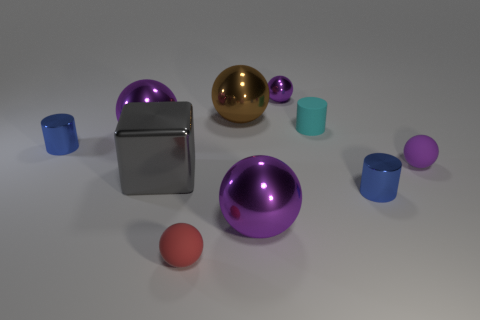Subtract all purple spheres. How many were subtracted if there are2purple spheres left? 2 Subtract all metallic cylinders. How many cylinders are left? 1 Subtract all cyan spheres. How many blue cylinders are left? 2 Subtract all brown balls. How many balls are left? 5 Subtract 1 cylinders. How many cylinders are left? 2 Subtract all cubes. How many objects are left? 9 Subtract all cyan spheres. Subtract all yellow cubes. How many spheres are left? 6 Add 5 small purple objects. How many small purple objects are left? 7 Add 5 tiny brown metallic blocks. How many tiny brown metallic blocks exist? 5 Subtract 0 cyan spheres. How many objects are left? 10 